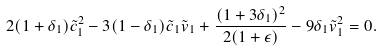Convert formula to latex. <formula><loc_0><loc_0><loc_500><loc_500>2 ( 1 + \delta _ { 1 } ) \tilde { c } _ { 1 } ^ { 2 } - 3 ( 1 - \delta _ { 1 } ) \tilde { c } _ { 1 } \tilde { v } _ { 1 } + \frac { ( 1 + 3 \delta _ { 1 } ) ^ { 2 } } { 2 ( 1 + \epsilon ) } - 9 \delta _ { 1 } \tilde { v } _ { 1 } ^ { 2 } = 0 .</formula> 